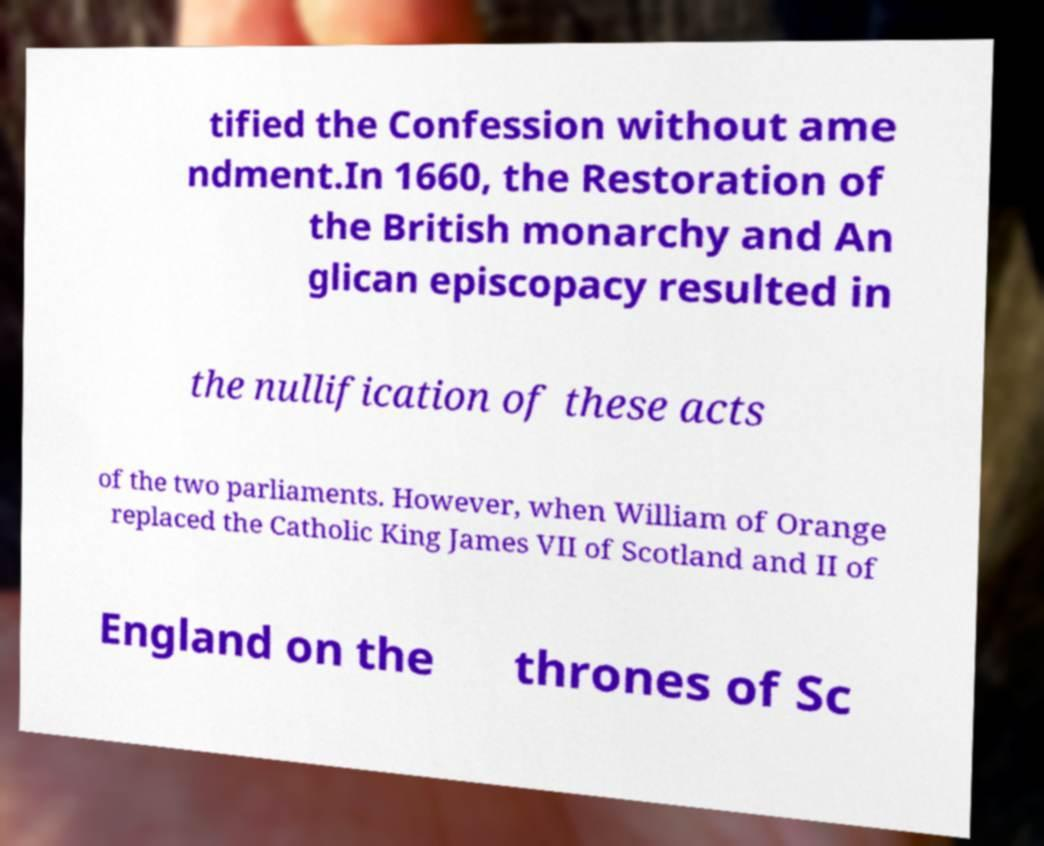I need the written content from this picture converted into text. Can you do that? tified the Confession without ame ndment.In 1660, the Restoration of the British monarchy and An glican episcopacy resulted in the nullification of these acts of the two parliaments. However, when William of Orange replaced the Catholic King James VII of Scotland and II of England on the thrones of Sc 